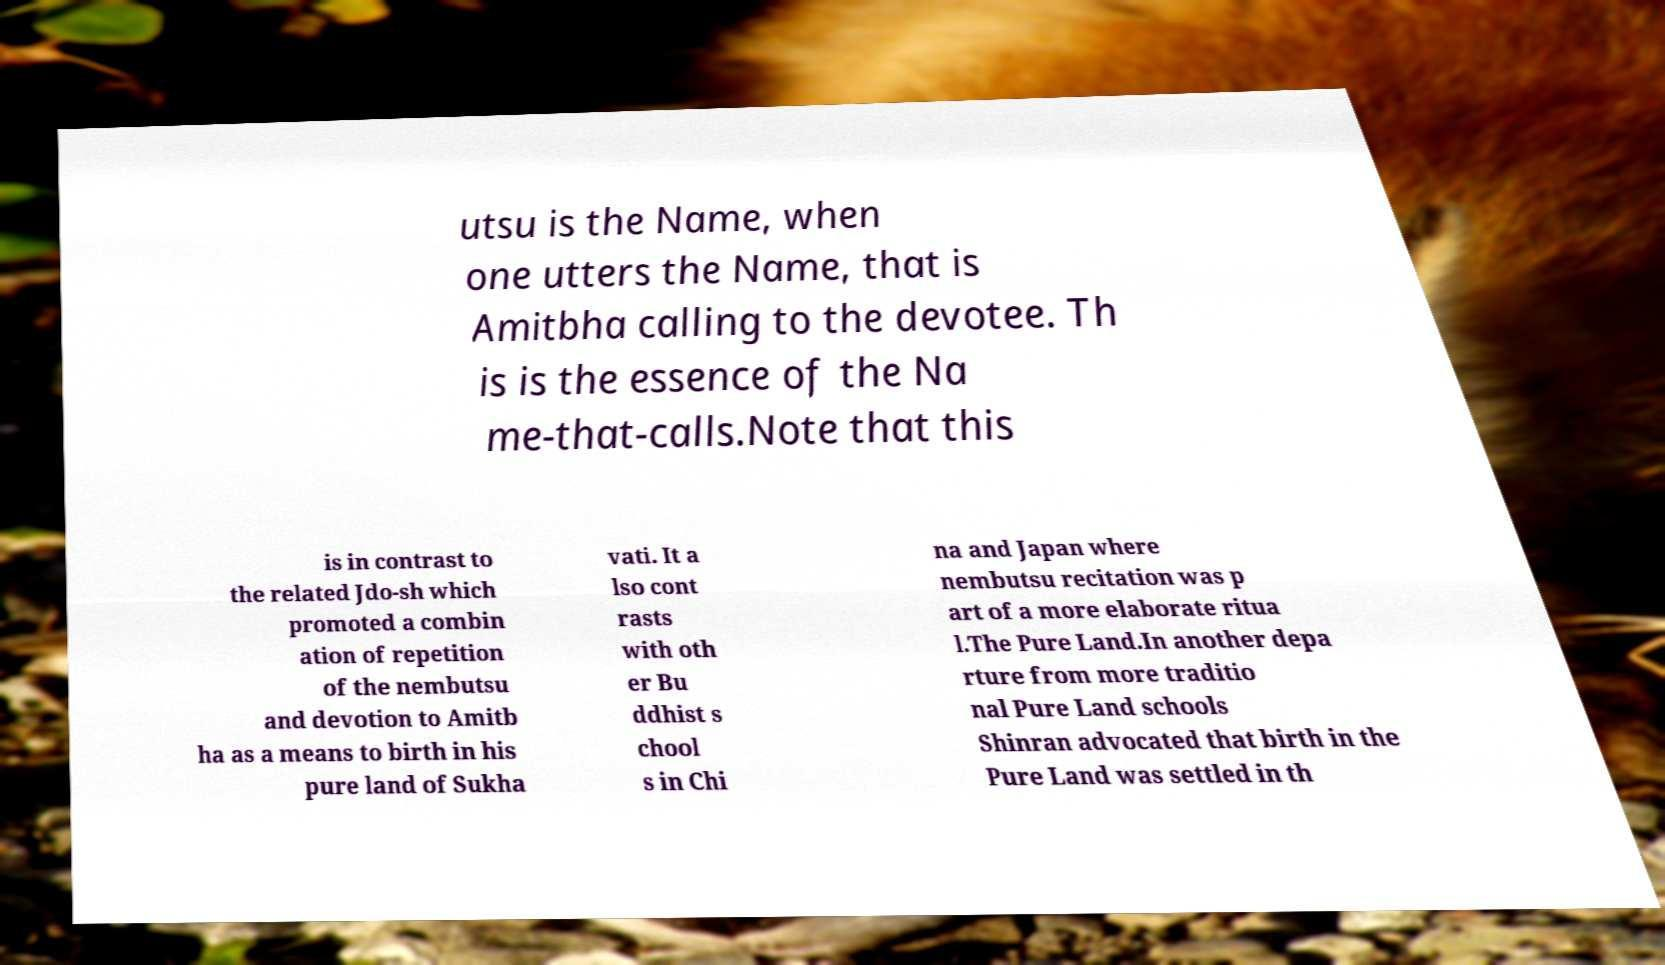Could you assist in decoding the text presented in this image and type it out clearly? utsu is the Name, when one utters the Name, that is Amitbha calling to the devotee. Th is is the essence of the Na me-that-calls.Note that this is in contrast to the related Jdo-sh which promoted a combin ation of repetition of the nembutsu and devotion to Amitb ha as a means to birth in his pure land of Sukha vati. It a lso cont rasts with oth er Bu ddhist s chool s in Chi na and Japan where nembutsu recitation was p art of a more elaborate ritua l.The Pure Land.In another depa rture from more traditio nal Pure Land schools Shinran advocated that birth in the Pure Land was settled in th 